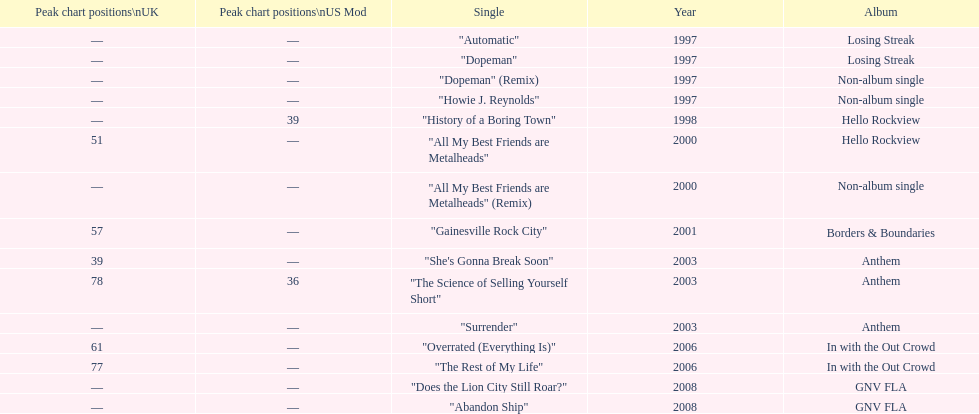Which album had the single automatic? Losing Streak. 